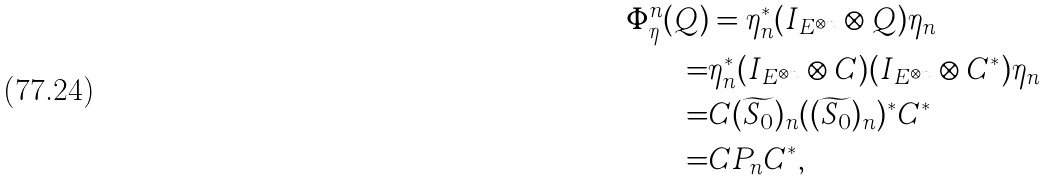<formula> <loc_0><loc_0><loc_500><loc_500>\Phi _ { \eta } ^ { n } ( Q ) & = \eta _ { n } ^ { * } ( I _ { E ^ { \otimes n } } \otimes Q ) \eta _ { n } \\ = & \eta _ { n } ^ { * } ( I _ { E ^ { \otimes n } } \otimes C ) ( I _ { E ^ { \otimes n } } \otimes C ^ { * } ) \eta _ { n } \\ = & C ( \widetilde { S _ { 0 } } ) _ { n } ( ( \widetilde { S _ { 0 } } ) _ { n } ) ^ { * } C ^ { * } \\ = & C P _ { n } C ^ { * } ,</formula> 